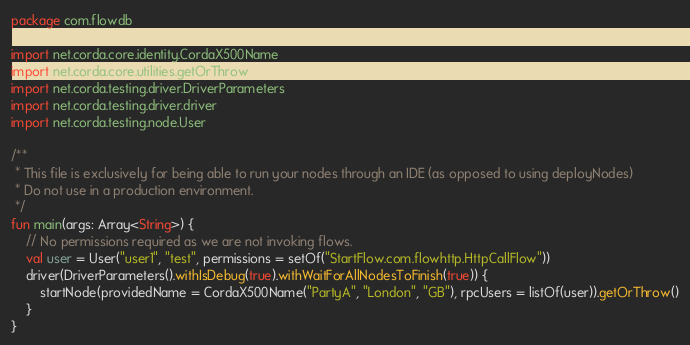<code> <loc_0><loc_0><loc_500><loc_500><_Kotlin_>package com.flowdb

import net.corda.core.identity.CordaX500Name
import net.corda.core.utilities.getOrThrow
import net.corda.testing.driver.DriverParameters
import net.corda.testing.driver.driver
import net.corda.testing.node.User

/**
 * This file is exclusively for being able to run your nodes through an IDE (as opposed to using deployNodes)
 * Do not use in a production environment.
 */
fun main(args: Array<String>) {
    // No permissions required as we are not invoking flows.
    val user = User("user1", "test", permissions = setOf("StartFlow.com.flowhttp.HttpCallFlow"))
    driver(DriverParameters().withIsDebug(true).withWaitForAllNodesToFinish(true)) {
        startNode(providedName = CordaX500Name("PartyA", "London", "GB"), rpcUsers = listOf(user)).getOrThrow()
    }
}</code> 